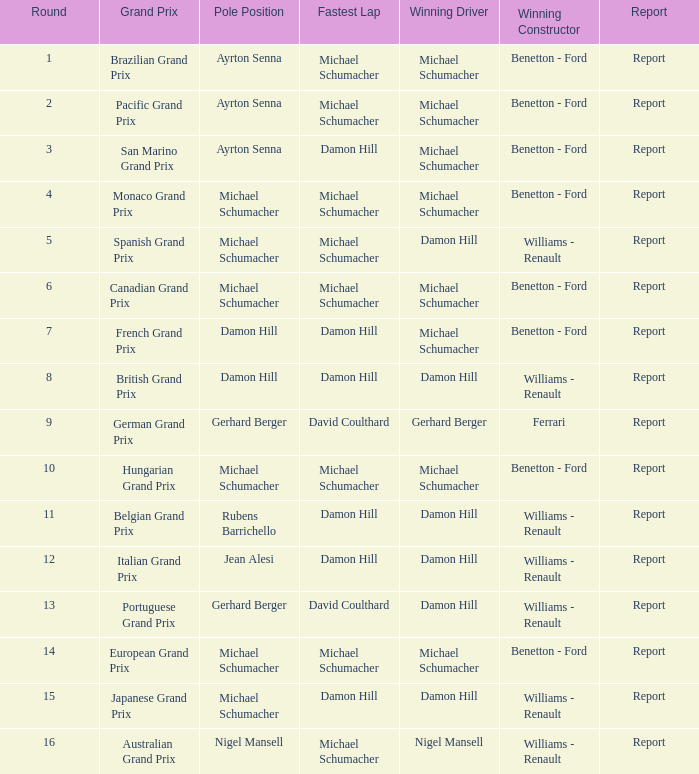Name the fastest lap for the brazilian grand prix Michael Schumacher. 